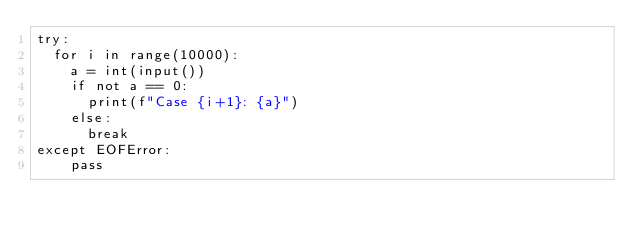<code> <loc_0><loc_0><loc_500><loc_500><_Python_>try:
  for i in range(10000):
    a = int(input())
    if not a == 0:
      print(f"Case {i+1}: {a}")
    else:
      break
except EOFError:
    pass
</code> 